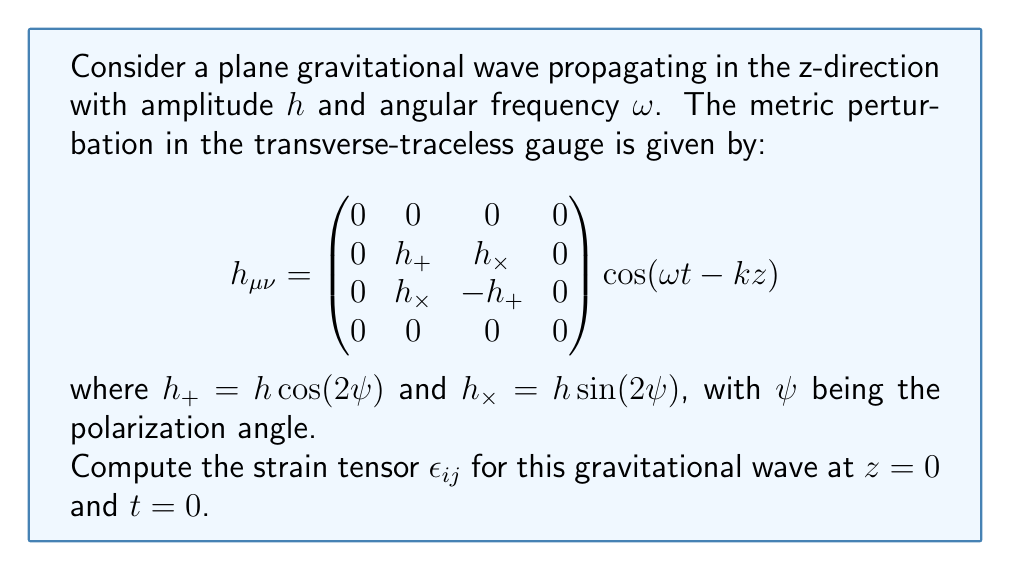Provide a solution to this math problem. To compute the strain tensor, we follow these steps:

1) The strain tensor $\epsilon_{ij}$ is related to the metric perturbation $h_{ij}$ by:

   $$\epsilon_{ij} = \frac{1}{2} h_{ij}$$

2) At $z=0$ and $t=0$, $\cos(\omega t - kz) = 1$, so we can ignore this term.

3) The non-zero components of $h_{ij}$ are:

   $$h_{11} = h_+ = h \cos(2\psi)$$
   $$h_{22} = -h_+ = -h \cos(2\psi)$$
   $$h_{12} = h_{21} = h_\times = h \sin(2\psi)$$

4) Applying the relation from step 1 to each component:

   $$\epsilon_{11} = \frac{1}{2} h \cos(2\psi)$$
   $$\epsilon_{22} = -\frac{1}{2} h \cos(2\psi)$$
   $$\epsilon_{12} = \epsilon_{21} = \frac{1}{2} h \sin(2\psi)$$

5) All other components (involving index 3) are zero.

6) Therefore, the strain tensor is:

   $$\epsilon_{ij} = \frac{1}{2} \begin{pmatrix}
   h \cos(2\psi) & h \sin(2\psi) & 0 \\
   h \sin(2\psi) & -h \cos(2\psi) & 0 \\
   0 & 0 & 0
   \end{pmatrix}$$
Answer: $$\epsilon_{ij} = \frac{h}{2} \begin{pmatrix}
\cos(2\psi) & \sin(2\psi) & 0 \\
\sin(2\psi) & -\cos(2\psi) & 0 \\
0 & 0 & 0
\end{pmatrix}$$ 